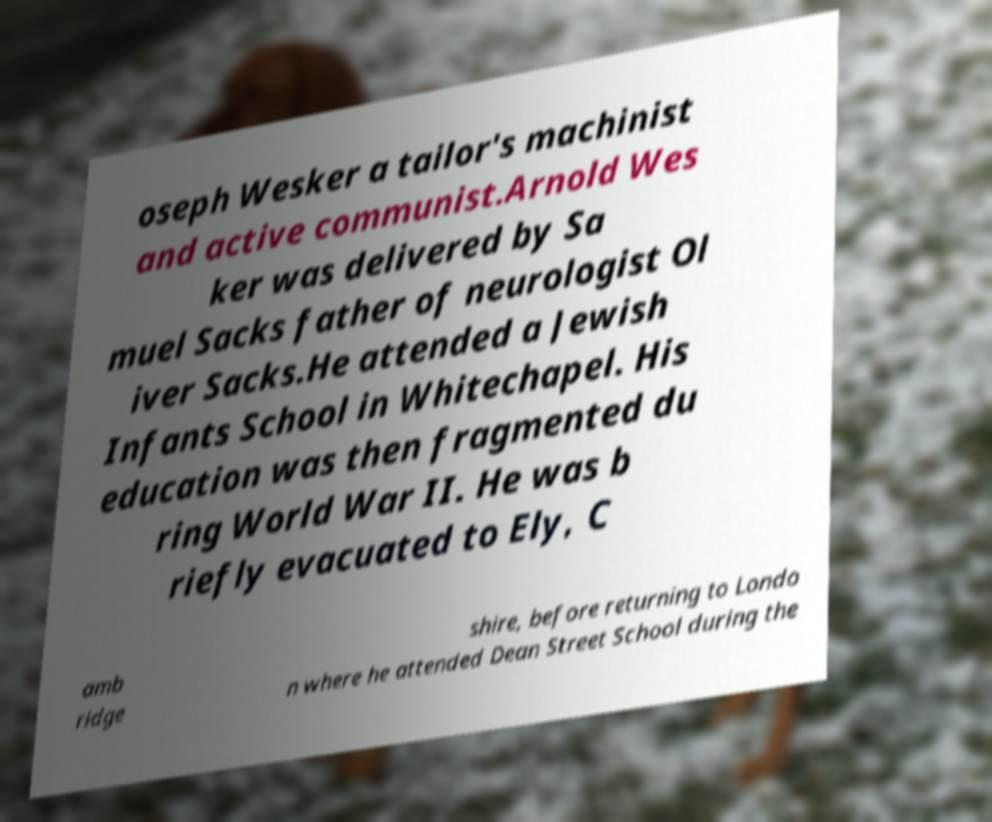For documentation purposes, I need the text within this image transcribed. Could you provide that? oseph Wesker a tailor's machinist and active communist.Arnold Wes ker was delivered by Sa muel Sacks father of neurologist Ol iver Sacks.He attended a Jewish Infants School in Whitechapel. His education was then fragmented du ring World War II. He was b riefly evacuated to Ely, C amb ridge shire, before returning to Londo n where he attended Dean Street School during the 